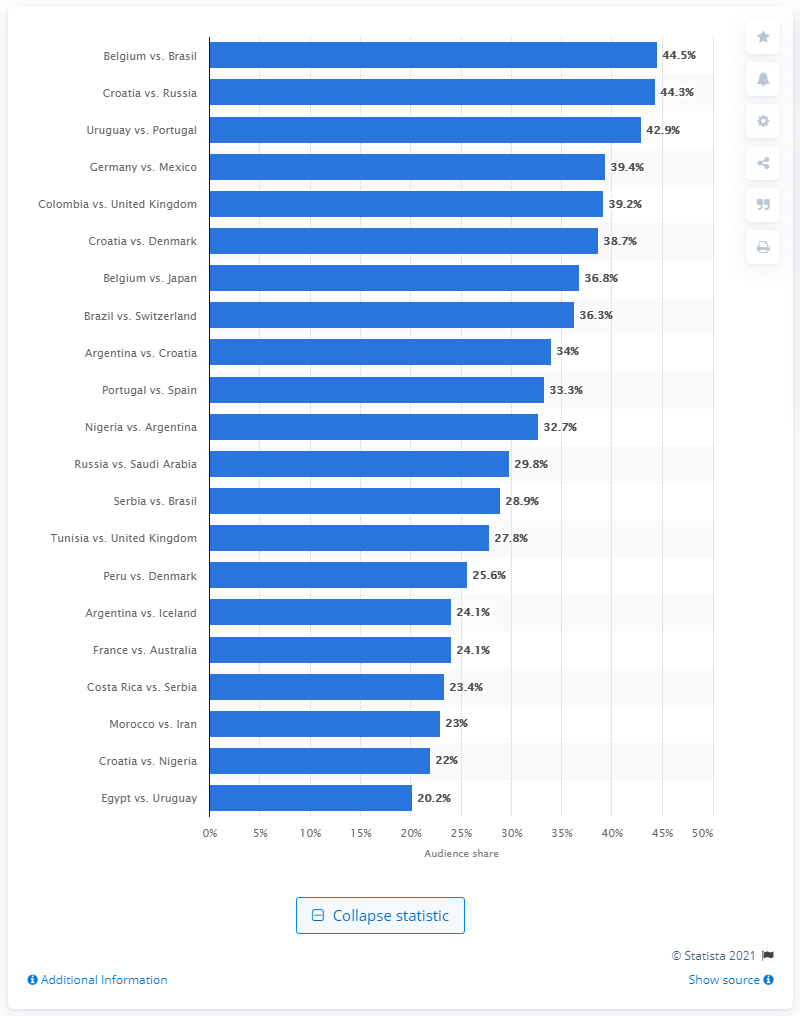Point out several critical features in this image. The audience share of the match between Belgium and Brazil in 2018 was 44.5%. 